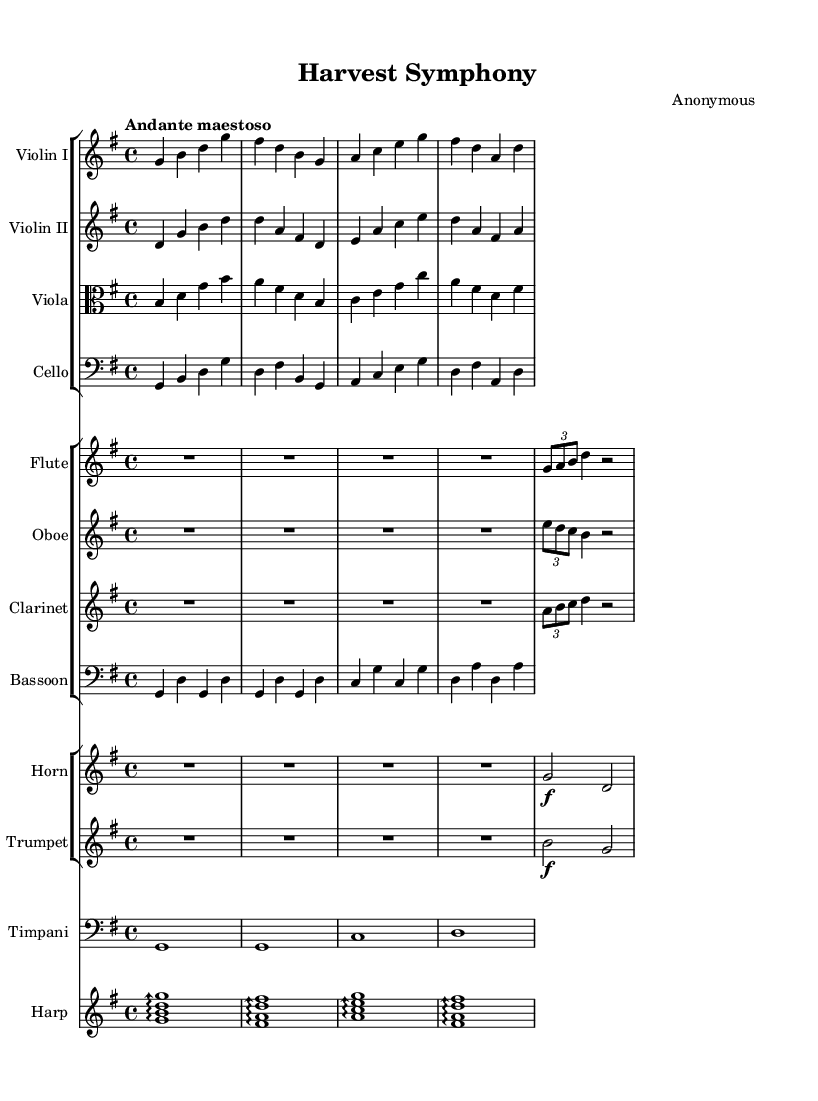What is the key signature of this music? The key signature is G major, which has one sharp, F#. This can be observed at the beginning of the staff where the sharps are indicated.
Answer: G major What is the time signature of this music? The time signature is 4/4, which indicates that there are four beats in each measure. This can be found at the beginning of the piece, written as a fraction.
Answer: 4/4 What is the tempo marking for this piece? The tempo marking is "Andante maestoso," which suggests a moderately slow and majestic pace. This is indicated above the staff at the beginning of the piece.
Answer: Andante maestoso How many different instruments are featured in this sheet music? The score features a total of ten different instruments, which are commonly used in orchestral compositions. Each instrument is listed on its own staff within the score.
Answer: Ten Which instrument is indicated to play a bird call motif? The flute, oboe, and clarinet are noted to play a bird call motif, as indicated by the rest followed by the tuplet notation at the beginning of their respective parts.
Answer: Flute, Oboe, Clarinet What indicates the use of dynamics in this music? The dynamics in this music are indicated by markings such as "f" for forte and "pp" for pianissimo, which are placed before the notes to show how loudly or softly they should be played.
Answer: Dynamics markings 